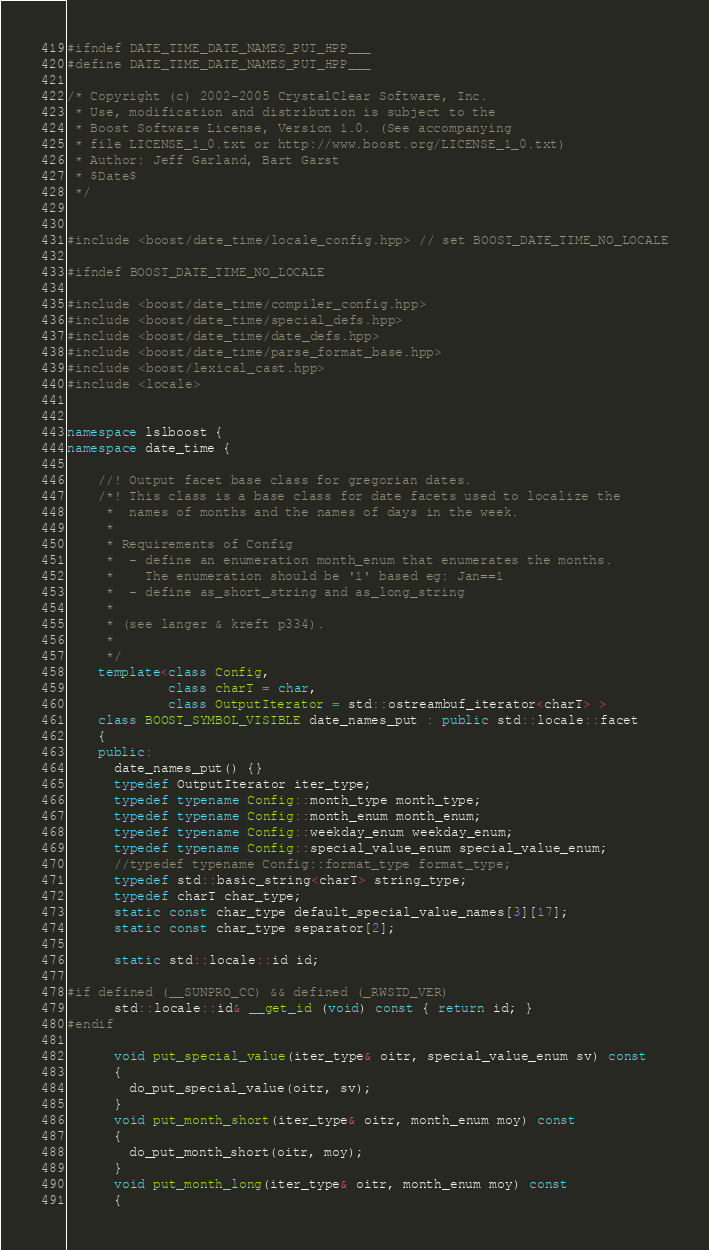Convert code to text. <code><loc_0><loc_0><loc_500><loc_500><_C++_>#ifndef DATE_TIME_DATE_NAMES_PUT_HPP___
#define DATE_TIME_DATE_NAMES_PUT_HPP___

/* Copyright (c) 2002-2005 CrystalClear Software, Inc.
 * Use, modification and distribution is subject to the
 * Boost Software License, Version 1.0. (See accompanying
 * file LICENSE_1_0.txt or http://www.boost.org/LICENSE_1_0.txt)
 * Author: Jeff Garland, Bart Garst
 * $Date$
 */


#include <boost/date_time/locale_config.hpp> // set BOOST_DATE_TIME_NO_LOCALE

#ifndef BOOST_DATE_TIME_NO_LOCALE

#include <boost/date_time/compiler_config.hpp>
#include <boost/date_time/special_defs.hpp>
#include <boost/date_time/date_defs.hpp>
#include <boost/date_time/parse_format_base.hpp>
#include <boost/lexical_cast.hpp>
#include <locale>


namespace lslboost {
namespace date_time {

    //! Output facet base class for gregorian dates.
    /*! This class is a base class for date facets used to localize the
     *  names of months and the names of days in the week.
     *
     * Requirements of Config
     *  - define an enumeration month_enum that enumerates the months.
     *    The enumeration should be '1' based eg: Jan==1
     *  - define as_short_string and as_long_string
     *
     * (see langer & kreft p334).
     *
     */
    template<class Config,
             class charT = char,
             class OutputIterator = std::ostreambuf_iterator<charT> >
    class BOOST_SYMBOL_VISIBLE date_names_put : public std::locale::facet
    {
    public:
      date_names_put() {}
      typedef OutputIterator iter_type;
      typedef typename Config::month_type month_type;
      typedef typename Config::month_enum month_enum;
      typedef typename Config::weekday_enum weekday_enum;
      typedef typename Config::special_value_enum special_value_enum;
      //typedef typename Config::format_type format_type;
      typedef std::basic_string<charT> string_type;
      typedef charT char_type;
      static const char_type default_special_value_names[3][17];
      static const char_type separator[2];

      static std::locale::id id;

#if defined (__SUNPRO_CC) && defined (_RWSTD_VER)
      std::locale::id& __get_id (void) const { return id; }
#endif

      void put_special_value(iter_type& oitr, special_value_enum sv) const
      {
        do_put_special_value(oitr, sv);
      }
      void put_month_short(iter_type& oitr, month_enum moy) const
      {
        do_put_month_short(oitr, moy);
      }
      void put_month_long(iter_type& oitr, month_enum moy) const
      {</code> 